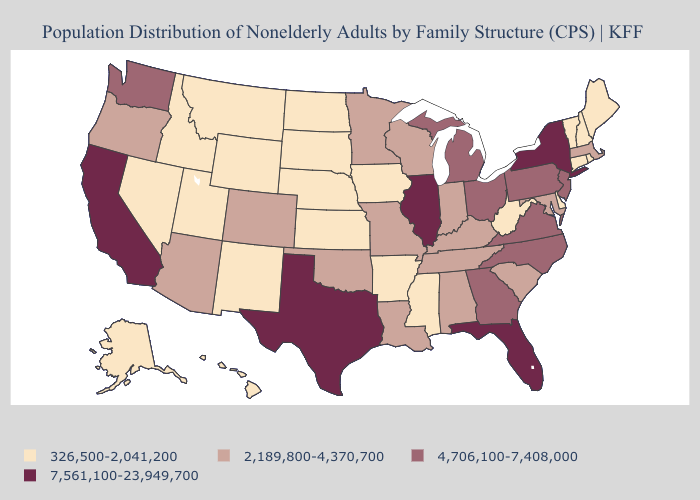Does the first symbol in the legend represent the smallest category?
Short answer required. Yes. What is the highest value in states that border Delaware?
Write a very short answer. 4,706,100-7,408,000. Does New York have the highest value in the Northeast?
Answer briefly. Yes. What is the value of Alaska?
Answer briefly. 326,500-2,041,200. Does Michigan have the highest value in the USA?
Be succinct. No. Which states have the lowest value in the Northeast?
Be succinct. Connecticut, Maine, New Hampshire, Rhode Island, Vermont. Which states have the lowest value in the Northeast?
Answer briefly. Connecticut, Maine, New Hampshire, Rhode Island, Vermont. What is the value of South Dakota?
Keep it brief. 326,500-2,041,200. What is the value of Montana?
Quick response, please. 326,500-2,041,200. Does Idaho have the highest value in the USA?
Short answer required. No. Name the states that have a value in the range 326,500-2,041,200?
Answer briefly. Alaska, Arkansas, Connecticut, Delaware, Hawaii, Idaho, Iowa, Kansas, Maine, Mississippi, Montana, Nebraska, Nevada, New Hampshire, New Mexico, North Dakota, Rhode Island, South Dakota, Utah, Vermont, West Virginia, Wyoming. What is the highest value in states that border Connecticut?
Give a very brief answer. 7,561,100-23,949,700. Which states have the lowest value in the West?
Be succinct. Alaska, Hawaii, Idaho, Montana, Nevada, New Mexico, Utah, Wyoming. What is the highest value in the MidWest ?
Concise answer only. 7,561,100-23,949,700. 